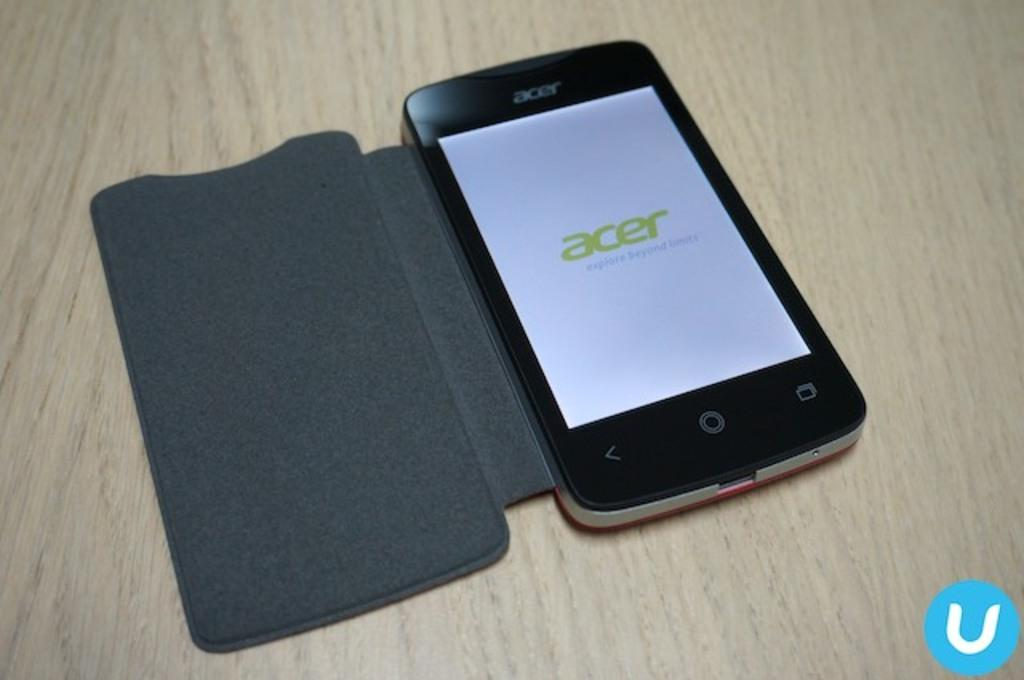<image>
Render a clear and concise summary of the photo. An Acer phone is turned on a sitting on a table with the cover open. 